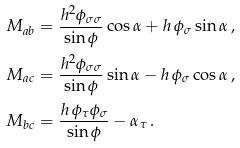<formula> <loc_0><loc_0><loc_500><loc_500>M _ { a b } & = \frac { h ^ { 2 } \phi _ { \sigma \sigma } } { \sin \phi } \cos \alpha + h \, \phi _ { \sigma } \sin \alpha \, , \\ M _ { a c } & = \frac { h ^ { 2 } \phi _ { \sigma \sigma } } { \sin \phi } \sin \alpha - h \, \phi _ { \sigma } \cos \alpha \, , \\ M _ { b c } & = \frac { h \, \phi _ { \tau } \phi _ { \sigma } } { \sin \phi } - \alpha _ { \tau } \, .</formula> 